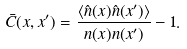<formula> <loc_0><loc_0><loc_500><loc_500>\bar { C } ( x , x ^ { \prime } ) = \frac { \langle \hat { n } ( x ) \hat { n } ( x ^ { \prime } ) \rangle } { n ( x ) n ( x ^ { \prime } ) } - 1 .</formula> 